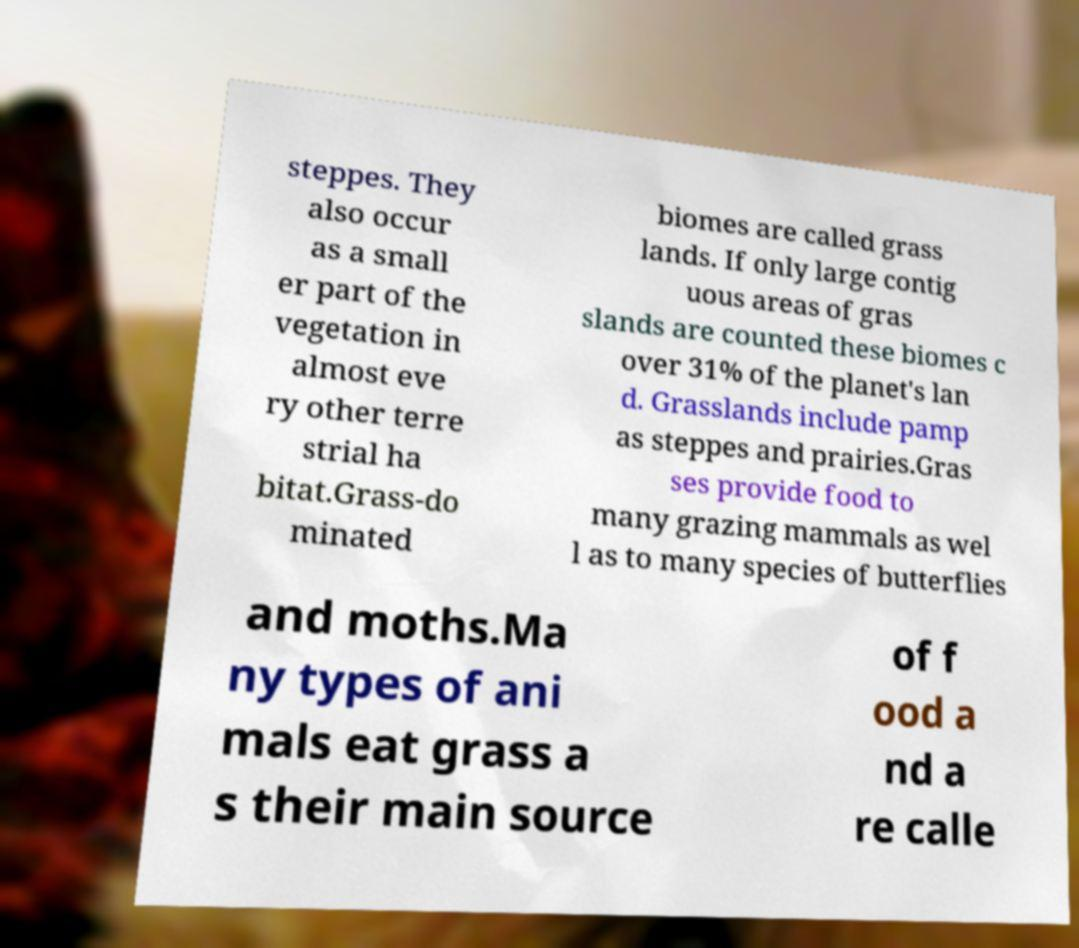Please identify and transcribe the text found in this image. steppes. They also occur as a small er part of the vegetation in almost eve ry other terre strial ha bitat.Grass-do minated biomes are called grass lands. If only large contig uous areas of gras slands are counted these biomes c over 31% of the planet's lan d. Grasslands include pamp as steppes and prairies.Gras ses provide food to many grazing mammals as wel l as to many species of butterflies and moths.Ma ny types of ani mals eat grass a s their main source of f ood a nd a re calle 